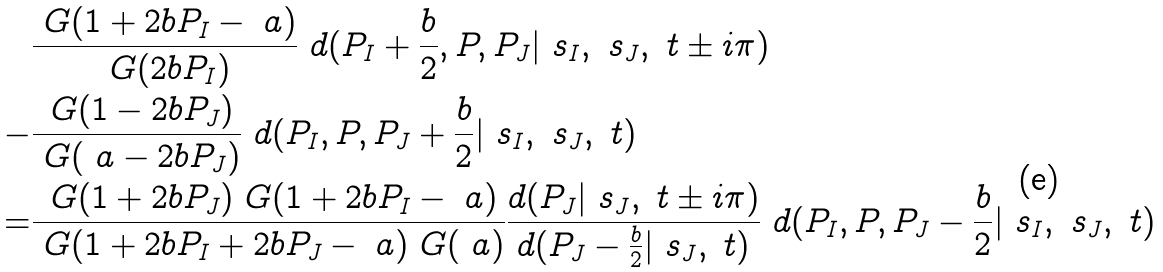Convert formula to latex. <formula><loc_0><loc_0><loc_500><loc_500>& \frac { \ G ( 1 + 2 b P _ { I } - \ a ) } { \ G ( 2 b P _ { I } ) } \ d ( P _ { I } + \frac { b } { 2 } , P , P _ { J } | \ s _ { I } , \ s _ { J } , \ t \pm i \pi ) \\ - & \frac { \ G ( 1 - 2 b P _ { J } ) } { \ G ( \ a - 2 b P _ { J } ) } \ d ( P _ { I } , P , P _ { J } + \frac { b } { 2 } | \ s _ { I } , \ s _ { J } , \ t ) \\ = & \frac { \ G ( 1 + 2 b P _ { J } ) \ G ( 1 + 2 b P _ { I } - \ a ) } { \ G ( 1 + 2 b P _ { I } + 2 b P _ { J } - \ a ) \ G ( \ a ) } \frac { d ( P _ { J } | \ s _ { J } , \ t \pm i \pi ) } { d ( P _ { J } - \frac { b } { 2 } | \ s _ { J } , \ t ) } \ d ( P _ { I } , P , P _ { J } - \frac { b } { 2 } | \ s _ { I } , \ s _ { J } , \ t )</formula> 